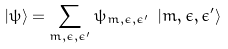<formula> <loc_0><loc_0><loc_500><loc_500>| \psi \rangle = \sum _ { m , \epsilon , \epsilon ^ { \prime } } \psi _ { m , \epsilon , \epsilon ^ { \prime } } \ | m , \epsilon , \epsilon ^ { \prime } \rangle</formula> 